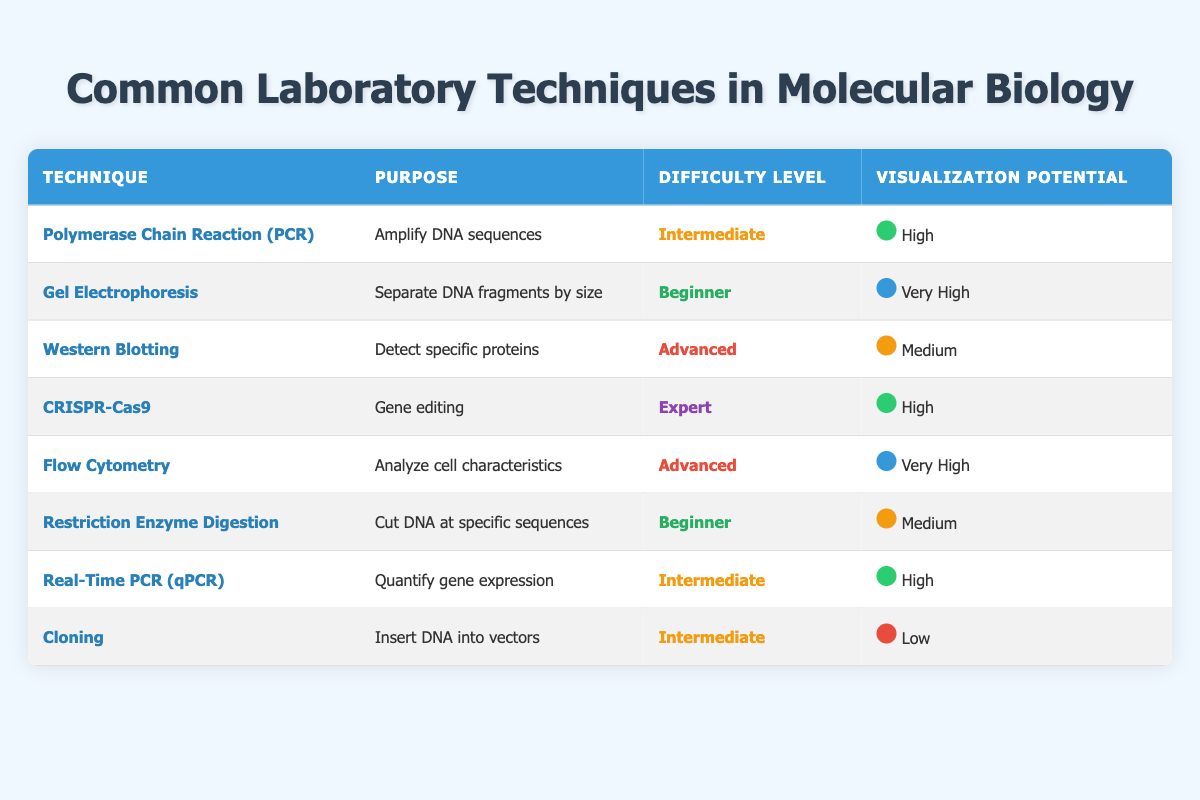What is the purpose of Gel Electrophoresis? The table states that Gel Electrophoresis is used to 'Separate DNA fragments by size.' This is a direct retrieval of information from the 'Purpose' column corresponding to the 'Gel Electrophoresis' technique.
Answer: Separate DNA fragments by size How many techniques have a Difficulty Level marked as 'Advanced'? In the table, two techniques are marked as 'Advanced': Western Blotting and Flow Cytometry. By counting those entries, we conclude there are two such techniques.
Answer: 2 Is the visualization potential of Cloning low? A quick check of the 'Visualization Potential' column for Cloning shows that it is marked as 'Low.' Thus, the statement holds true based on the table.
Answer: Yes What technique is used for gene editing? The technique listed for gene editing in the table is CRISPR-Cas9. This can be verified by looking at the 'Purpose' column for that specific technique.
Answer: CRISPR-Cas9 What is the average difficulty level of the provided techniques? The difficulty levels are Beginner, Intermediate, Advanced, and Expert. We can assign numerical values (Beginner=1, Intermediate=2, Advanced=3, Expert=4) and calculate the average. There are 8 techniques, totaling 1 (for Restriction Enzyme Digestion) + 1 (for Gel Electrophoresis) + 2 (for PCR) + 2 (for Real-Time PCR) + 3 (for Western Blotting and Flow Cytometry) + 4 (for CRISPR) + 2 (for Cloning) = 16. Therefore, the average difficulty level is 16/8 = 2 or Intermediate.
Answer: Intermediate Which technique has the highest visualization potential? When reviewing the 'Visualization Potential' column, Gel Electrophoresis and Flow Cytometry are both marked as 'Very High.' Since no technique exceeds this rating, the highest potential is classified as 'Very High.'
Answer: Gel Electrophoresis and Flow Cytometry 